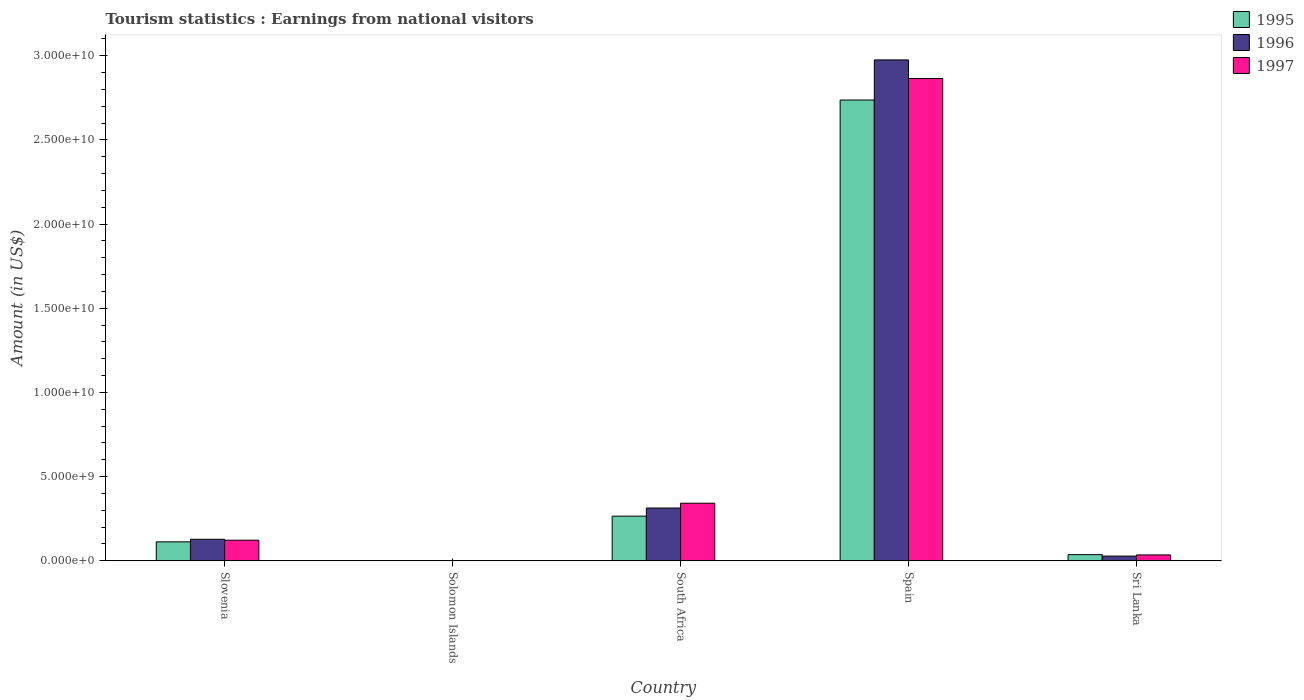How many different coloured bars are there?
Provide a short and direct response. 3. How many groups of bars are there?
Make the answer very short. 5. Are the number of bars per tick equal to the number of legend labels?
Your answer should be compact. Yes. How many bars are there on the 5th tick from the left?
Offer a very short reply. 3. How many bars are there on the 5th tick from the right?
Ensure brevity in your answer.  3. What is the label of the 5th group of bars from the left?
Your answer should be compact. Sri Lanka. In how many cases, is the number of bars for a given country not equal to the number of legend labels?
Keep it short and to the point. 0. What is the earnings from national visitors in 1997 in Spain?
Offer a very short reply. 2.86e+1. Across all countries, what is the maximum earnings from national visitors in 1996?
Your answer should be very brief. 2.98e+1. Across all countries, what is the minimum earnings from national visitors in 1995?
Your response must be concise. 1.71e+07. In which country was the earnings from national visitors in 1995 minimum?
Provide a short and direct response. Solomon Islands. What is the total earnings from national visitors in 1996 in the graph?
Your answer should be compact. 3.45e+1. What is the difference between the earnings from national visitors in 1997 in Slovenia and that in Spain?
Your answer should be compact. -2.74e+1. What is the difference between the earnings from national visitors in 1997 in South Africa and the earnings from national visitors in 1996 in Solomon Islands?
Keep it short and to the point. 3.41e+09. What is the average earnings from national visitors in 1996 per country?
Your response must be concise. 6.89e+09. What is the difference between the earnings from national visitors of/in 1997 and earnings from national visitors of/in 1995 in Slovenia?
Give a very brief answer. 9.70e+07. In how many countries, is the earnings from national visitors in 1995 greater than 28000000000 US$?
Keep it short and to the point. 0. What is the ratio of the earnings from national visitors in 1996 in Solomon Islands to that in Spain?
Provide a short and direct response. 0. Is the earnings from national visitors in 1995 in South Africa less than that in Spain?
Offer a very short reply. Yes. Is the difference between the earnings from national visitors in 1997 in Solomon Islands and Spain greater than the difference between the earnings from national visitors in 1995 in Solomon Islands and Spain?
Give a very brief answer. No. What is the difference between the highest and the second highest earnings from national visitors in 1996?
Ensure brevity in your answer.  2.85e+1. What is the difference between the highest and the lowest earnings from national visitors in 1996?
Offer a very short reply. 2.97e+1. Is the sum of the earnings from national visitors in 1995 in South Africa and Sri Lanka greater than the maximum earnings from national visitors in 1996 across all countries?
Offer a terse response. No. Is it the case that in every country, the sum of the earnings from national visitors in 1997 and earnings from national visitors in 1995 is greater than the earnings from national visitors in 1996?
Make the answer very short. Yes. How many bars are there?
Offer a terse response. 15. How many countries are there in the graph?
Make the answer very short. 5. Where does the legend appear in the graph?
Ensure brevity in your answer.  Top right. How many legend labels are there?
Make the answer very short. 3. What is the title of the graph?
Offer a very short reply. Tourism statistics : Earnings from national visitors. Does "1977" appear as one of the legend labels in the graph?
Provide a short and direct response. No. What is the label or title of the X-axis?
Provide a short and direct response. Country. What is the Amount (in US$) of 1995 in Slovenia?
Provide a succinct answer. 1.13e+09. What is the Amount (in US$) in 1996 in Slovenia?
Ensure brevity in your answer.  1.28e+09. What is the Amount (in US$) in 1997 in Slovenia?
Make the answer very short. 1.22e+09. What is the Amount (in US$) of 1995 in Solomon Islands?
Keep it short and to the point. 1.71e+07. What is the Amount (in US$) in 1996 in Solomon Islands?
Offer a very short reply. 1.60e+07. What is the Amount (in US$) of 1997 in Solomon Islands?
Make the answer very short. 9.70e+06. What is the Amount (in US$) in 1995 in South Africa?
Make the answer very short. 2.65e+09. What is the Amount (in US$) in 1996 in South Africa?
Your response must be concise. 3.14e+09. What is the Amount (in US$) of 1997 in South Africa?
Your answer should be compact. 3.42e+09. What is the Amount (in US$) in 1995 in Spain?
Make the answer very short. 2.74e+1. What is the Amount (in US$) in 1996 in Spain?
Give a very brief answer. 2.98e+1. What is the Amount (in US$) of 1997 in Spain?
Provide a succinct answer. 2.86e+1. What is the Amount (in US$) in 1995 in Sri Lanka?
Offer a very short reply. 3.67e+08. What is the Amount (in US$) in 1996 in Sri Lanka?
Keep it short and to the point. 2.82e+08. What is the Amount (in US$) in 1997 in Sri Lanka?
Ensure brevity in your answer.  3.51e+08. Across all countries, what is the maximum Amount (in US$) of 1995?
Provide a succinct answer. 2.74e+1. Across all countries, what is the maximum Amount (in US$) in 1996?
Offer a very short reply. 2.98e+1. Across all countries, what is the maximum Amount (in US$) of 1997?
Keep it short and to the point. 2.86e+1. Across all countries, what is the minimum Amount (in US$) of 1995?
Provide a short and direct response. 1.71e+07. Across all countries, what is the minimum Amount (in US$) of 1996?
Give a very brief answer. 1.60e+07. Across all countries, what is the minimum Amount (in US$) of 1997?
Your response must be concise. 9.70e+06. What is the total Amount (in US$) of 1995 in the graph?
Make the answer very short. 3.15e+1. What is the total Amount (in US$) of 1996 in the graph?
Your answer should be compact. 3.45e+1. What is the total Amount (in US$) of 1997 in the graph?
Provide a succinct answer. 3.37e+1. What is the difference between the Amount (in US$) in 1995 in Slovenia and that in Solomon Islands?
Ensure brevity in your answer.  1.11e+09. What is the difference between the Amount (in US$) in 1996 in Slovenia and that in Solomon Islands?
Offer a terse response. 1.26e+09. What is the difference between the Amount (in US$) of 1997 in Slovenia and that in Solomon Islands?
Your answer should be compact. 1.22e+09. What is the difference between the Amount (in US$) of 1995 in Slovenia and that in South Africa?
Give a very brief answer. -1.53e+09. What is the difference between the Amount (in US$) of 1996 in Slovenia and that in South Africa?
Make the answer very short. -1.86e+09. What is the difference between the Amount (in US$) of 1997 in Slovenia and that in South Africa?
Keep it short and to the point. -2.20e+09. What is the difference between the Amount (in US$) in 1995 in Slovenia and that in Spain?
Keep it short and to the point. -2.62e+1. What is the difference between the Amount (in US$) of 1996 in Slovenia and that in Spain?
Give a very brief answer. -2.85e+1. What is the difference between the Amount (in US$) of 1997 in Slovenia and that in Spain?
Keep it short and to the point. -2.74e+1. What is the difference between the Amount (in US$) in 1995 in Slovenia and that in Sri Lanka?
Make the answer very short. 7.61e+08. What is the difference between the Amount (in US$) of 1996 in Slovenia and that in Sri Lanka?
Offer a very short reply. 9.98e+08. What is the difference between the Amount (in US$) of 1997 in Slovenia and that in Sri Lanka?
Give a very brief answer. 8.74e+08. What is the difference between the Amount (in US$) in 1995 in Solomon Islands and that in South Africa?
Your answer should be compact. -2.64e+09. What is the difference between the Amount (in US$) in 1996 in Solomon Islands and that in South Africa?
Your response must be concise. -3.12e+09. What is the difference between the Amount (in US$) of 1997 in Solomon Islands and that in South Africa?
Offer a terse response. -3.41e+09. What is the difference between the Amount (in US$) of 1995 in Solomon Islands and that in Spain?
Provide a succinct answer. -2.74e+1. What is the difference between the Amount (in US$) of 1996 in Solomon Islands and that in Spain?
Ensure brevity in your answer.  -2.97e+1. What is the difference between the Amount (in US$) in 1997 in Solomon Islands and that in Spain?
Make the answer very short. -2.86e+1. What is the difference between the Amount (in US$) in 1995 in Solomon Islands and that in Sri Lanka?
Your answer should be very brief. -3.50e+08. What is the difference between the Amount (in US$) of 1996 in Solomon Islands and that in Sri Lanka?
Keep it short and to the point. -2.66e+08. What is the difference between the Amount (in US$) in 1997 in Solomon Islands and that in Sri Lanka?
Keep it short and to the point. -3.41e+08. What is the difference between the Amount (in US$) in 1995 in South Africa and that in Spain?
Give a very brief answer. -2.47e+1. What is the difference between the Amount (in US$) in 1996 in South Africa and that in Spain?
Offer a terse response. -2.66e+1. What is the difference between the Amount (in US$) in 1997 in South Africa and that in Spain?
Provide a succinct answer. -2.52e+1. What is the difference between the Amount (in US$) of 1995 in South Africa and that in Sri Lanka?
Your answer should be compact. 2.29e+09. What is the difference between the Amount (in US$) of 1996 in South Africa and that in Sri Lanka?
Offer a terse response. 2.86e+09. What is the difference between the Amount (in US$) of 1997 in South Africa and that in Sri Lanka?
Offer a very short reply. 3.07e+09. What is the difference between the Amount (in US$) in 1995 in Spain and that in Sri Lanka?
Keep it short and to the point. 2.70e+1. What is the difference between the Amount (in US$) in 1996 in Spain and that in Sri Lanka?
Provide a succinct answer. 2.95e+1. What is the difference between the Amount (in US$) of 1997 in Spain and that in Sri Lanka?
Offer a terse response. 2.83e+1. What is the difference between the Amount (in US$) in 1995 in Slovenia and the Amount (in US$) in 1996 in Solomon Islands?
Give a very brief answer. 1.11e+09. What is the difference between the Amount (in US$) in 1995 in Slovenia and the Amount (in US$) in 1997 in Solomon Islands?
Give a very brief answer. 1.12e+09. What is the difference between the Amount (in US$) in 1996 in Slovenia and the Amount (in US$) in 1997 in Solomon Islands?
Offer a terse response. 1.27e+09. What is the difference between the Amount (in US$) in 1995 in Slovenia and the Amount (in US$) in 1996 in South Africa?
Ensure brevity in your answer.  -2.01e+09. What is the difference between the Amount (in US$) in 1995 in Slovenia and the Amount (in US$) in 1997 in South Africa?
Your answer should be very brief. -2.29e+09. What is the difference between the Amount (in US$) in 1996 in Slovenia and the Amount (in US$) in 1997 in South Africa?
Make the answer very short. -2.14e+09. What is the difference between the Amount (in US$) in 1995 in Slovenia and the Amount (in US$) in 1996 in Spain?
Your answer should be very brief. -2.86e+1. What is the difference between the Amount (in US$) in 1995 in Slovenia and the Amount (in US$) in 1997 in Spain?
Ensure brevity in your answer.  -2.75e+1. What is the difference between the Amount (in US$) in 1996 in Slovenia and the Amount (in US$) in 1997 in Spain?
Keep it short and to the point. -2.74e+1. What is the difference between the Amount (in US$) in 1995 in Slovenia and the Amount (in US$) in 1996 in Sri Lanka?
Give a very brief answer. 8.46e+08. What is the difference between the Amount (in US$) of 1995 in Slovenia and the Amount (in US$) of 1997 in Sri Lanka?
Your answer should be compact. 7.77e+08. What is the difference between the Amount (in US$) in 1996 in Slovenia and the Amount (in US$) in 1997 in Sri Lanka?
Offer a very short reply. 9.29e+08. What is the difference between the Amount (in US$) in 1995 in Solomon Islands and the Amount (in US$) in 1996 in South Africa?
Your response must be concise. -3.12e+09. What is the difference between the Amount (in US$) in 1995 in Solomon Islands and the Amount (in US$) in 1997 in South Africa?
Offer a very short reply. -3.40e+09. What is the difference between the Amount (in US$) in 1996 in Solomon Islands and the Amount (in US$) in 1997 in South Africa?
Make the answer very short. -3.41e+09. What is the difference between the Amount (in US$) in 1995 in Solomon Islands and the Amount (in US$) in 1996 in Spain?
Your answer should be compact. -2.97e+1. What is the difference between the Amount (in US$) of 1995 in Solomon Islands and the Amount (in US$) of 1997 in Spain?
Provide a succinct answer. -2.86e+1. What is the difference between the Amount (in US$) of 1996 in Solomon Islands and the Amount (in US$) of 1997 in Spain?
Provide a short and direct response. -2.86e+1. What is the difference between the Amount (in US$) in 1995 in Solomon Islands and the Amount (in US$) in 1996 in Sri Lanka?
Your answer should be compact. -2.65e+08. What is the difference between the Amount (in US$) in 1995 in Solomon Islands and the Amount (in US$) in 1997 in Sri Lanka?
Your answer should be very brief. -3.34e+08. What is the difference between the Amount (in US$) of 1996 in Solomon Islands and the Amount (in US$) of 1997 in Sri Lanka?
Provide a succinct answer. -3.35e+08. What is the difference between the Amount (in US$) of 1995 in South Africa and the Amount (in US$) of 1996 in Spain?
Give a very brief answer. -2.71e+1. What is the difference between the Amount (in US$) of 1995 in South Africa and the Amount (in US$) of 1997 in Spain?
Provide a short and direct response. -2.60e+1. What is the difference between the Amount (in US$) in 1996 in South Africa and the Amount (in US$) in 1997 in Spain?
Ensure brevity in your answer.  -2.55e+1. What is the difference between the Amount (in US$) in 1995 in South Africa and the Amount (in US$) in 1996 in Sri Lanka?
Provide a short and direct response. 2.37e+09. What is the difference between the Amount (in US$) in 1995 in South Africa and the Amount (in US$) in 1997 in Sri Lanka?
Your answer should be compact. 2.30e+09. What is the difference between the Amount (in US$) in 1996 in South Africa and the Amount (in US$) in 1997 in Sri Lanka?
Offer a very short reply. 2.79e+09. What is the difference between the Amount (in US$) in 1995 in Spain and the Amount (in US$) in 1996 in Sri Lanka?
Offer a terse response. 2.71e+1. What is the difference between the Amount (in US$) of 1995 in Spain and the Amount (in US$) of 1997 in Sri Lanka?
Offer a very short reply. 2.70e+1. What is the difference between the Amount (in US$) of 1996 in Spain and the Amount (in US$) of 1997 in Sri Lanka?
Offer a terse response. 2.94e+1. What is the average Amount (in US$) of 1995 per country?
Your response must be concise. 6.31e+09. What is the average Amount (in US$) of 1996 per country?
Your response must be concise. 6.89e+09. What is the average Amount (in US$) of 1997 per country?
Your answer should be compact. 6.73e+09. What is the difference between the Amount (in US$) in 1995 and Amount (in US$) in 1996 in Slovenia?
Make the answer very short. -1.52e+08. What is the difference between the Amount (in US$) of 1995 and Amount (in US$) of 1997 in Slovenia?
Offer a very short reply. -9.70e+07. What is the difference between the Amount (in US$) of 1996 and Amount (in US$) of 1997 in Slovenia?
Provide a succinct answer. 5.50e+07. What is the difference between the Amount (in US$) of 1995 and Amount (in US$) of 1996 in Solomon Islands?
Your answer should be compact. 1.10e+06. What is the difference between the Amount (in US$) in 1995 and Amount (in US$) in 1997 in Solomon Islands?
Offer a terse response. 7.40e+06. What is the difference between the Amount (in US$) of 1996 and Amount (in US$) of 1997 in Solomon Islands?
Your response must be concise. 6.30e+06. What is the difference between the Amount (in US$) of 1995 and Amount (in US$) of 1996 in South Africa?
Give a very brief answer. -4.83e+08. What is the difference between the Amount (in US$) in 1995 and Amount (in US$) in 1997 in South Africa?
Provide a succinct answer. -7.68e+08. What is the difference between the Amount (in US$) of 1996 and Amount (in US$) of 1997 in South Africa?
Your response must be concise. -2.85e+08. What is the difference between the Amount (in US$) of 1995 and Amount (in US$) of 1996 in Spain?
Provide a succinct answer. -2.38e+09. What is the difference between the Amount (in US$) of 1995 and Amount (in US$) of 1997 in Spain?
Your answer should be compact. -1.28e+09. What is the difference between the Amount (in US$) in 1996 and Amount (in US$) in 1997 in Spain?
Keep it short and to the point. 1.10e+09. What is the difference between the Amount (in US$) in 1995 and Amount (in US$) in 1996 in Sri Lanka?
Your answer should be compact. 8.50e+07. What is the difference between the Amount (in US$) of 1995 and Amount (in US$) of 1997 in Sri Lanka?
Ensure brevity in your answer.  1.60e+07. What is the difference between the Amount (in US$) of 1996 and Amount (in US$) of 1997 in Sri Lanka?
Provide a succinct answer. -6.90e+07. What is the ratio of the Amount (in US$) of 1995 in Slovenia to that in Solomon Islands?
Ensure brevity in your answer.  65.96. What is the ratio of the Amount (in US$) in 1997 in Slovenia to that in Solomon Islands?
Your answer should be compact. 126.29. What is the ratio of the Amount (in US$) of 1995 in Slovenia to that in South Africa?
Your answer should be very brief. 0.42. What is the ratio of the Amount (in US$) of 1996 in Slovenia to that in South Africa?
Ensure brevity in your answer.  0.41. What is the ratio of the Amount (in US$) of 1997 in Slovenia to that in South Africa?
Make the answer very short. 0.36. What is the ratio of the Amount (in US$) in 1995 in Slovenia to that in Spain?
Keep it short and to the point. 0.04. What is the ratio of the Amount (in US$) of 1996 in Slovenia to that in Spain?
Your answer should be compact. 0.04. What is the ratio of the Amount (in US$) in 1997 in Slovenia to that in Spain?
Offer a terse response. 0.04. What is the ratio of the Amount (in US$) of 1995 in Slovenia to that in Sri Lanka?
Offer a terse response. 3.07. What is the ratio of the Amount (in US$) of 1996 in Slovenia to that in Sri Lanka?
Make the answer very short. 4.54. What is the ratio of the Amount (in US$) in 1997 in Slovenia to that in Sri Lanka?
Provide a short and direct response. 3.49. What is the ratio of the Amount (in US$) of 1995 in Solomon Islands to that in South Africa?
Make the answer very short. 0.01. What is the ratio of the Amount (in US$) in 1996 in Solomon Islands to that in South Africa?
Your answer should be compact. 0.01. What is the ratio of the Amount (in US$) of 1997 in Solomon Islands to that in South Africa?
Offer a very short reply. 0. What is the ratio of the Amount (in US$) in 1995 in Solomon Islands to that in Spain?
Your response must be concise. 0. What is the ratio of the Amount (in US$) of 1995 in Solomon Islands to that in Sri Lanka?
Make the answer very short. 0.05. What is the ratio of the Amount (in US$) of 1996 in Solomon Islands to that in Sri Lanka?
Give a very brief answer. 0.06. What is the ratio of the Amount (in US$) in 1997 in Solomon Islands to that in Sri Lanka?
Offer a terse response. 0.03. What is the ratio of the Amount (in US$) in 1995 in South Africa to that in Spain?
Ensure brevity in your answer.  0.1. What is the ratio of the Amount (in US$) of 1996 in South Africa to that in Spain?
Ensure brevity in your answer.  0.11. What is the ratio of the Amount (in US$) of 1997 in South Africa to that in Spain?
Ensure brevity in your answer.  0.12. What is the ratio of the Amount (in US$) of 1995 in South Africa to that in Sri Lanka?
Your answer should be very brief. 7.23. What is the ratio of the Amount (in US$) of 1996 in South Africa to that in Sri Lanka?
Offer a very short reply. 11.12. What is the ratio of the Amount (in US$) in 1997 in South Africa to that in Sri Lanka?
Offer a terse response. 9.75. What is the ratio of the Amount (in US$) in 1995 in Spain to that in Sri Lanka?
Offer a terse response. 74.57. What is the ratio of the Amount (in US$) in 1996 in Spain to that in Sri Lanka?
Provide a short and direct response. 105.5. What is the ratio of the Amount (in US$) of 1997 in Spain to that in Sri Lanka?
Your answer should be compact. 81.62. What is the difference between the highest and the second highest Amount (in US$) of 1995?
Keep it short and to the point. 2.47e+1. What is the difference between the highest and the second highest Amount (in US$) of 1996?
Provide a succinct answer. 2.66e+1. What is the difference between the highest and the second highest Amount (in US$) in 1997?
Offer a terse response. 2.52e+1. What is the difference between the highest and the lowest Amount (in US$) of 1995?
Provide a succinct answer. 2.74e+1. What is the difference between the highest and the lowest Amount (in US$) of 1996?
Make the answer very short. 2.97e+1. What is the difference between the highest and the lowest Amount (in US$) of 1997?
Give a very brief answer. 2.86e+1. 